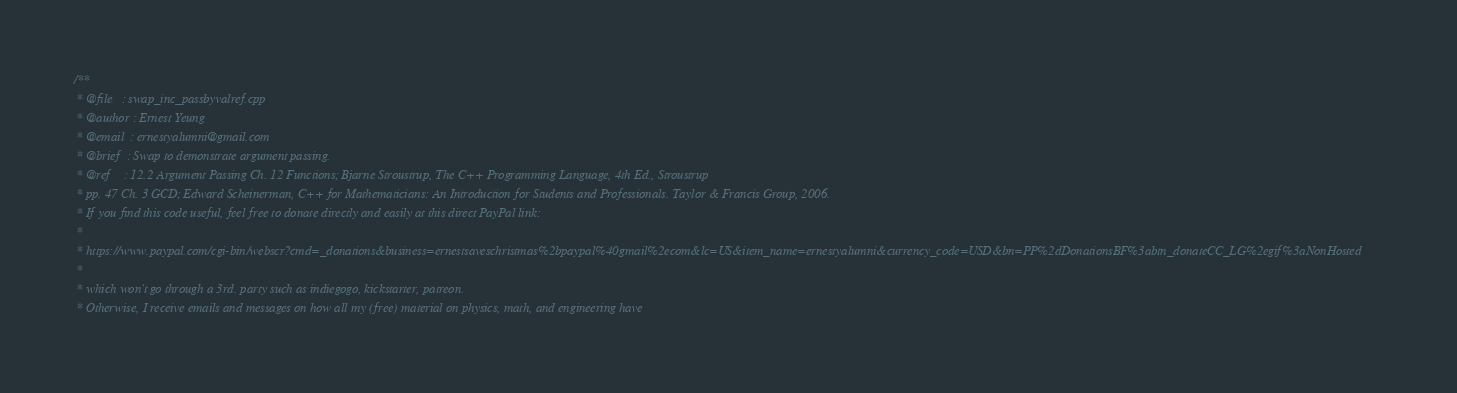Convert code to text. <code><loc_0><loc_0><loc_500><loc_500><_C++_>/**
 * @file   : swap_inc_passbyvalref.cpp
 * @author : Ernest Yeung
 * @email  : ernestyalumni@gmail.com
 * @brief  : Swap to demonstrate argument passing.
 * @ref    : 12.2 Argument Passing Ch. 12 Functions; Bjarne Stroustrup, The C++ Programming Language, 4th Ed., Stroustrup  
 * pp. 47 Ch. 3 GCD; Edward Scheinerman, C++ for Mathematicians: An Introduction for Students and Professionals. Taylor & Francis Group, 2006.   
 * If you find this code useful, feel free to donate directly and easily at this direct PayPal link: 
 * 
 * https://www.paypal.com/cgi-bin/webscr?cmd=_donations&business=ernestsaveschristmas%2bpaypal%40gmail%2ecom&lc=US&item_name=ernestyalumni&currency_code=USD&bn=PP%2dDonationsBF%3abtn_donateCC_LG%2egif%3aNonHosted 
 * 
 * which won't go through a 3rd. party such as indiegogo, kickstarter, patreon.  
 * Otherwise, I receive emails and messages on how all my (free) material on physics, math, and engineering have </code> 